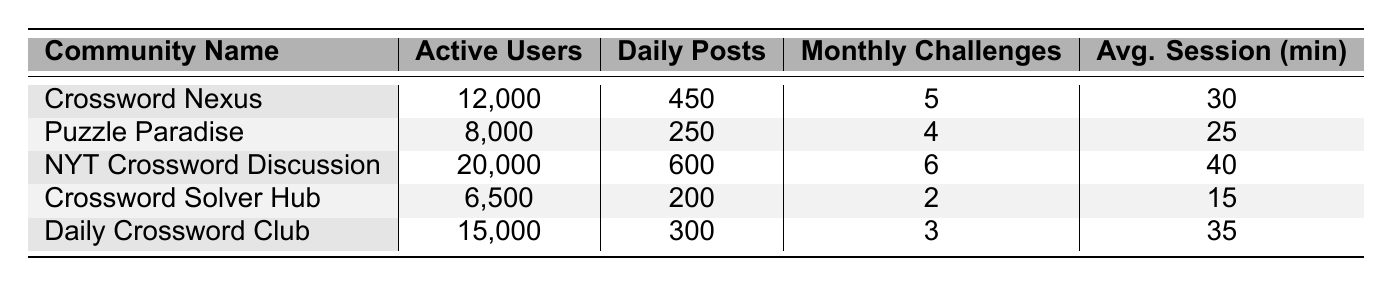What is the community with the highest number of active users? The table lists the active users for each community. The highest number among them is 20,000, which corresponds to the "NYT Crossword Discussion" community.
Answer: NYT Crossword Discussion How many daily posts does Puzzle Paradise have? Referring to the table, Puzzle Paradise has 250 daily posts listed under the "Daily Posts" column.
Answer: 250 What is the average session duration for the Crossword Solver Hub? The average session duration for the Crossword Solver Hub is mentioned in the table as 15 minutes in the "Avg. Session (min)" column.
Answer: 15 Which community has more active users: Daily Crossword Club or Crossword Nexus? The table shows Daily Crossword Club with 15,000 active users and Crossword Nexus with 12,000. Since 15,000 is greater than 12,000, Daily Crossword Club has more active users.
Answer: Daily Crossword Club What is the total number of monthly challenges across all communities? The monthly challenges for each community are 5, 4, 6, 2, and 3. Summing these gives 5 + 4 + 6 + 2 + 3 = 20 monthly challenges in total.
Answer: 20 Is the average session duration of NYT Crossword Discussion longer than that of Puzzle Paradise? The average session duration for NYT Crossword Discussion is 40 minutes and 25 minutes for Puzzle Paradise. Since 40 is greater than 25, the answer is yes.
Answer: Yes What is the difference in active users between the community with the highest and lowest active users? The highest active users is from NYT Crossword Discussion at 20,000, and the lowest is from Crossword Solver Hub at 6,500. The difference is 20,000 - 6,500 = 13,500.
Answer: 13,500 Calculate the average number of daily posts across all communities. The daily posts are 450, 250, 600, 200, and 300. Summing these gives 450 + 250 + 600 + 200 + 300 = 1800 daily posts. There are 5 communities, so the average is 1800 / 5 = 360.
Answer: 360 Does Daily Crossword Club have the highest number of monthly challenges? Checking the table, Daily Crossword Club has 3 monthly challenges, while NYT Crossword Discussion has 6. Thus, Daily Crossword Club does not have the highest.
Answer: No Which community has the least number of daily posts? The table shows that Crossword Solver Hub has 200 daily posts, which is the least among all communities listed.
Answer: Crossword Solver Hub 